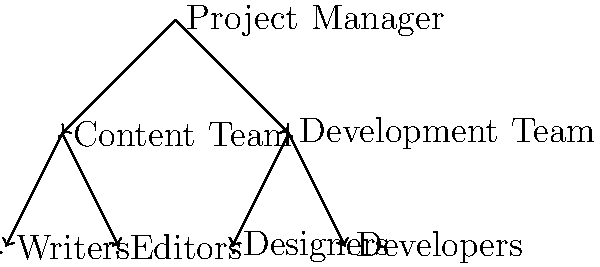In the collaborative project management system shown above, which team serves as the primary bridge between the content creation and software development processes? To determine the team that serves as the primary bridge between content creation and software development, let's analyze the hierarchical structure:

1. The Project Manager is at the top of the hierarchy, overseeing both the Content Team and Development Team.
2. The Content Team consists of Writers and Editors, focusing on content creation.
3. The Development Team includes Designers and Developers, responsible for software development.
4. As a software development team lead coordinating collaboration between content writers and software designers, you would be positioned between these two teams.
5. The Designers, part of the Development Team, typically work closely with both content creators and developers.
6. Designers translate content requirements into visual and functional elements, bridging the gap between written content and technical implementation.

Therefore, the Design team, represented by "Designers" in the diagram, serves as the primary bridge between content creation and software development processes.
Answer: Designers 